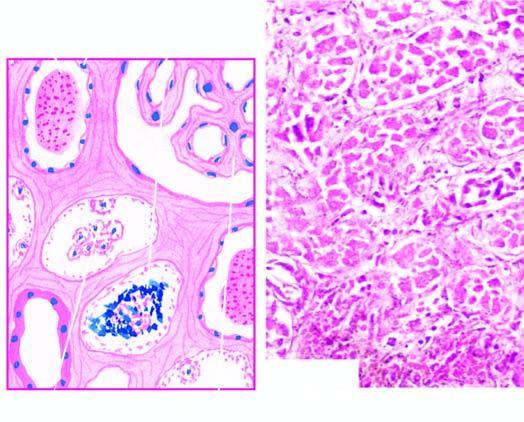does the tubular lumina contain casts and the regenerating flat epithelium lines the necrosed tubule?
Answer the question using a single word or phrase. Yes 